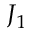Convert formula to latex. <formula><loc_0><loc_0><loc_500><loc_500>J _ { 1 }</formula> 